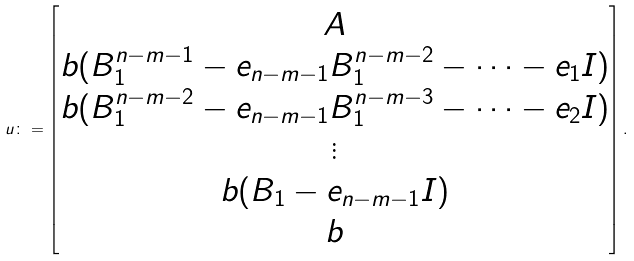Convert formula to latex. <formula><loc_0><loc_0><loc_500><loc_500>u \colon = \begin{bmatrix} A \\ b ( B _ { 1 } ^ { n - m - 1 } - e _ { n - m - 1 } B _ { 1 } ^ { n - m - 2 } - \cdots - e _ { 1 } I ) \\ b ( B _ { 1 } ^ { n - m - 2 } - e _ { n - m - 1 } B _ { 1 } ^ { n - m - 3 } - \cdots - e _ { 2 } I ) \\ \vdots \\ b ( B _ { 1 } - e _ { n - m - 1 } I ) \\ b \end{bmatrix} .</formula> 